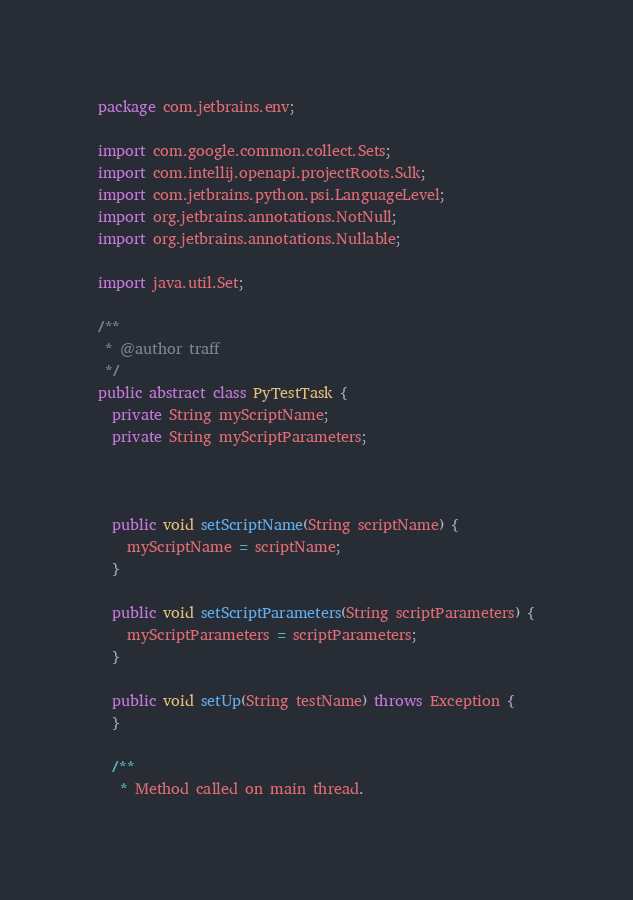<code> <loc_0><loc_0><loc_500><loc_500><_Java_>package com.jetbrains.env;

import com.google.common.collect.Sets;
import com.intellij.openapi.projectRoots.Sdk;
import com.jetbrains.python.psi.LanguageLevel;
import org.jetbrains.annotations.NotNull;
import org.jetbrains.annotations.Nullable;

import java.util.Set;

/**
 * @author traff
 */
public abstract class PyTestTask {
  private String myScriptName;
  private String myScriptParameters;



  public void setScriptName(String scriptName) {
    myScriptName = scriptName;
  }

  public void setScriptParameters(String scriptParameters) {
    myScriptParameters = scriptParameters;
  }

  public void setUp(String testName) throws Exception {
  }

  /**
   * Method called on main thread.</code> 